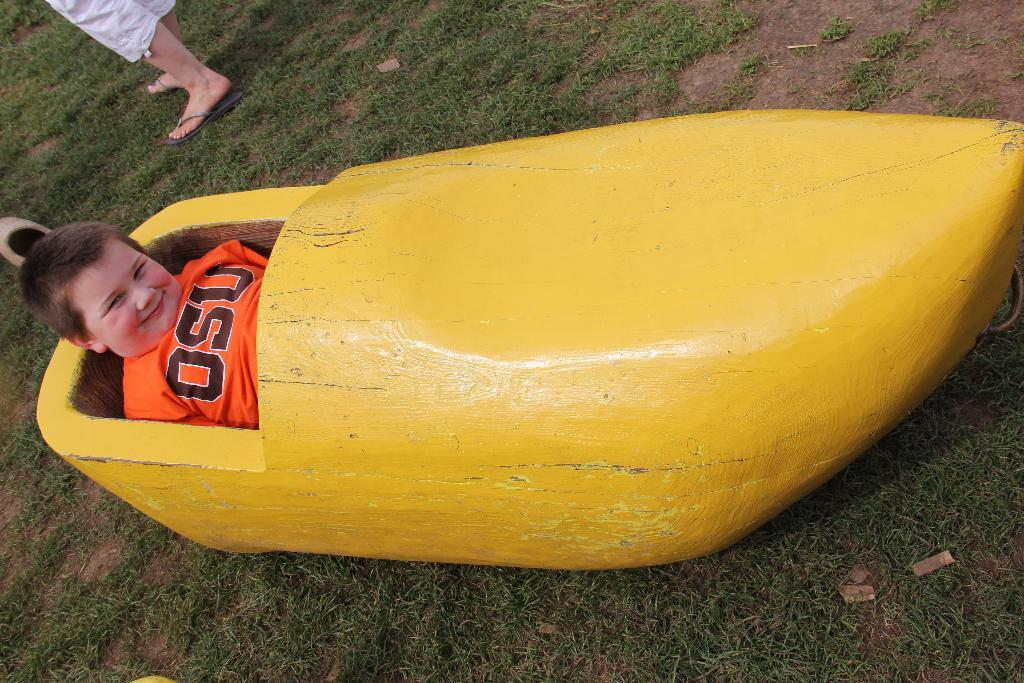<image>
Offer a succinct explanation of the picture presented. a child wearing an orange OSU shirt inside a yellow canoe 